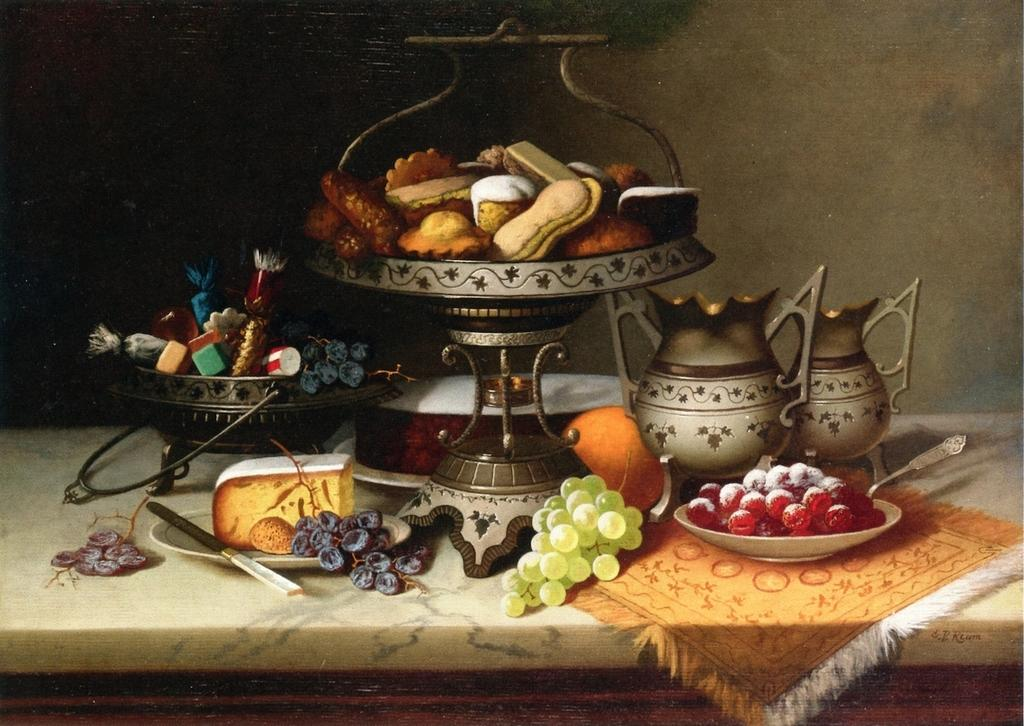What type of food items can be seen in the image? There are fruits in the image. What objects are used for serving or holding food in the image? There are plates, jars, and bowls in the image. What type of material is present for covering or cleaning purposes in the image? There is a cloth in the image. What can be seen in the background of the image? There is a wall in the background of the image. What is the plot of the story being told in the image? There is no story or plot depicted in the image; it simply shows fruits, plates, jars, bowls, a cloth, and a wall in the background. 